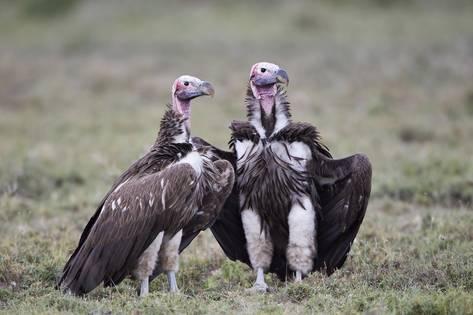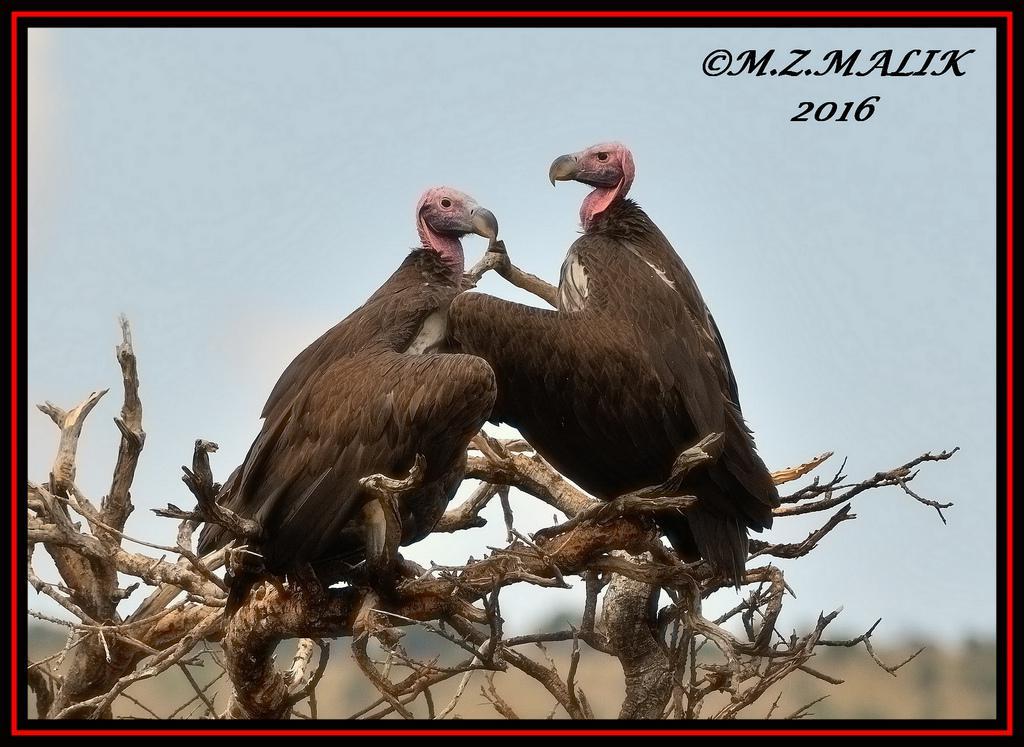The first image is the image on the left, the second image is the image on the right. Examine the images to the left and right. Is the description "An image contains no more than one vulture." accurate? Answer yes or no. No. 